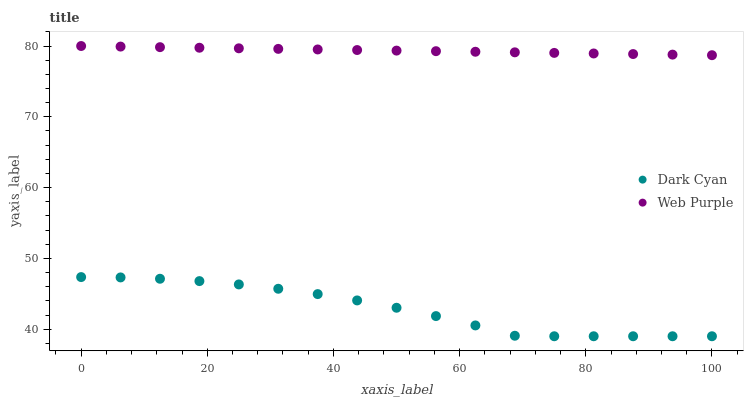Does Dark Cyan have the minimum area under the curve?
Answer yes or no. Yes. Does Web Purple have the maximum area under the curve?
Answer yes or no. Yes. Does Web Purple have the minimum area under the curve?
Answer yes or no. No. Is Web Purple the smoothest?
Answer yes or no. Yes. Is Dark Cyan the roughest?
Answer yes or no. Yes. Is Web Purple the roughest?
Answer yes or no. No. Does Dark Cyan have the lowest value?
Answer yes or no. Yes. Does Web Purple have the lowest value?
Answer yes or no. No. Does Web Purple have the highest value?
Answer yes or no. Yes. Is Dark Cyan less than Web Purple?
Answer yes or no. Yes. Is Web Purple greater than Dark Cyan?
Answer yes or no. Yes. Does Dark Cyan intersect Web Purple?
Answer yes or no. No. 